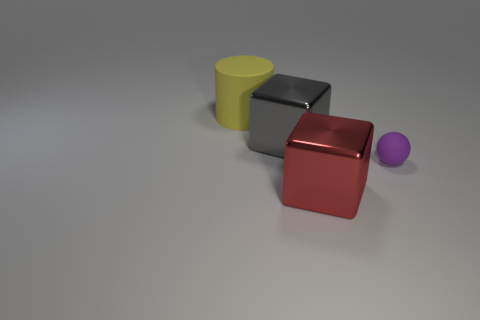Add 3 purple rubber things. How many objects exist? 7 Subtract all gray things. Subtract all red matte things. How many objects are left? 3 Add 1 big gray shiny blocks. How many big gray shiny blocks are left? 2 Add 1 rubber objects. How many rubber objects exist? 3 Subtract 0 green cylinders. How many objects are left? 4 